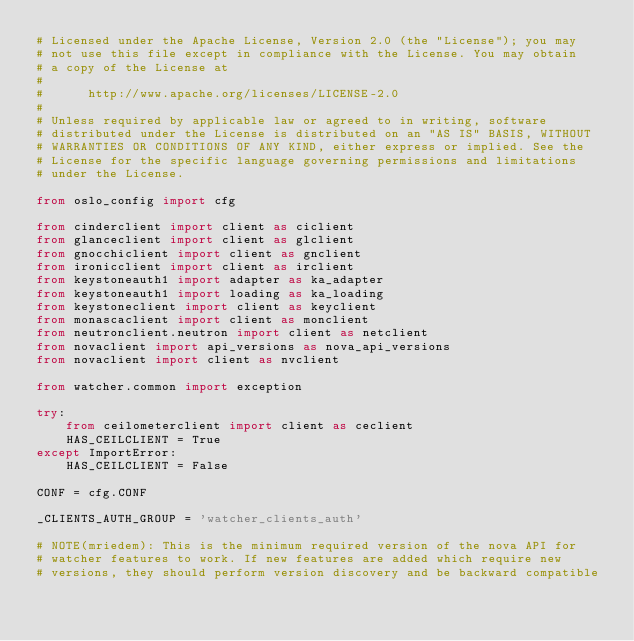Convert code to text. <code><loc_0><loc_0><loc_500><loc_500><_Python_># Licensed under the Apache License, Version 2.0 (the "License"); you may
# not use this file except in compliance with the License. You may obtain
# a copy of the License at
#
#      http://www.apache.org/licenses/LICENSE-2.0
#
# Unless required by applicable law or agreed to in writing, software
# distributed under the License is distributed on an "AS IS" BASIS, WITHOUT
# WARRANTIES OR CONDITIONS OF ANY KIND, either express or implied. See the
# License for the specific language governing permissions and limitations
# under the License.

from oslo_config import cfg

from cinderclient import client as ciclient
from glanceclient import client as glclient
from gnocchiclient import client as gnclient
from ironicclient import client as irclient
from keystoneauth1 import adapter as ka_adapter
from keystoneauth1 import loading as ka_loading
from keystoneclient import client as keyclient
from monascaclient import client as monclient
from neutronclient.neutron import client as netclient
from novaclient import api_versions as nova_api_versions
from novaclient import client as nvclient

from watcher.common import exception

try:
    from ceilometerclient import client as ceclient
    HAS_CEILCLIENT = True
except ImportError:
    HAS_CEILCLIENT = False

CONF = cfg.CONF

_CLIENTS_AUTH_GROUP = 'watcher_clients_auth'

# NOTE(mriedem): This is the minimum required version of the nova API for
# watcher features to work. If new features are added which require new
# versions, they should perform version discovery and be backward compatible</code> 